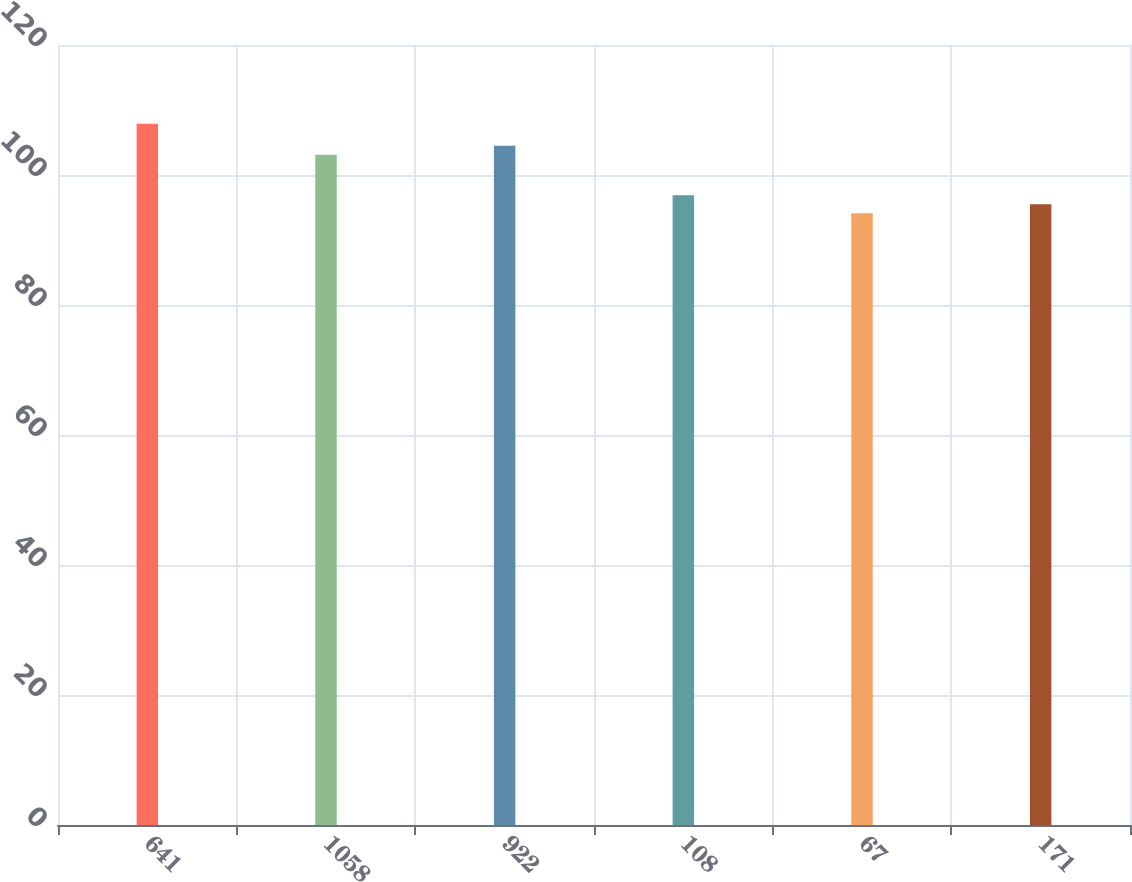Convert chart to OTSL. <chart><loc_0><loc_0><loc_500><loc_500><bar_chart><fcel>641<fcel>1058<fcel>922<fcel>108<fcel>67<fcel>171<nl><fcel>107.89<fcel>103.12<fcel>104.5<fcel>96.89<fcel>94.13<fcel>95.51<nl></chart> 